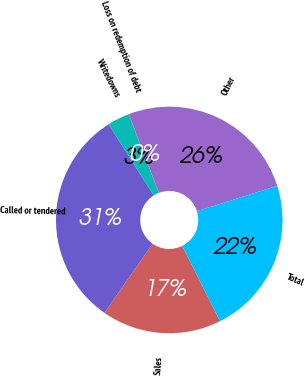Convert chart to OTSL. <chart><loc_0><loc_0><loc_500><loc_500><pie_chart><fcel>Sales<fcel>Called or tendered<fcel>Writedowns<fcel>Loss on redemption of debt<fcel>Other<fcel>Total<nl><fcel>17.09%<fcel>31.32%<fcel>3.15%<fcel>0.02%<fcel>25.94%<fcel>22.48%<nl></chart> 